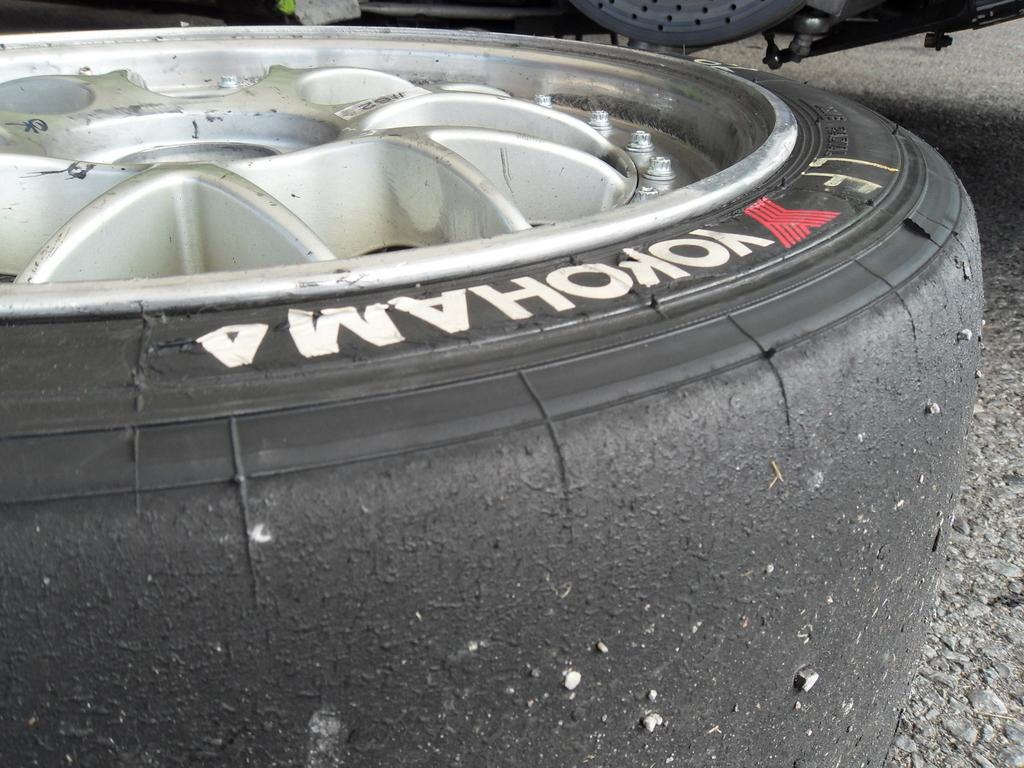Could you give a brief overview of what you see in this image? In the picture we can see a part of the tire with a rim and on the tire we can see a name YOKOHAMA. 